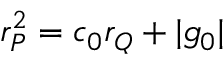<formula> <loc_0><loc_0><loc_500><loc_500>r _ { P } ^ { 2 } = c _ { 0 } r _ { Q } + | g _ { 0 } |</formula> 